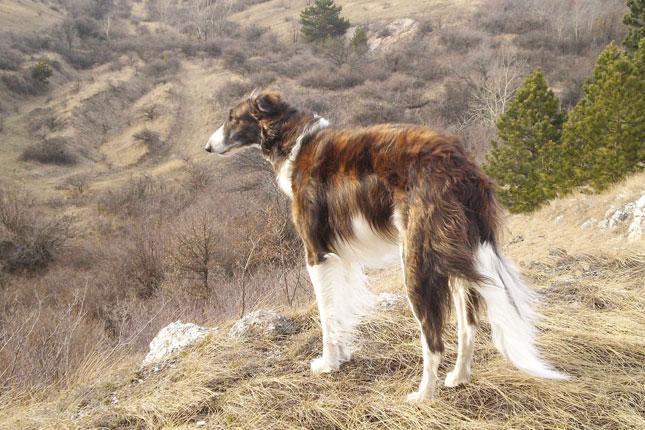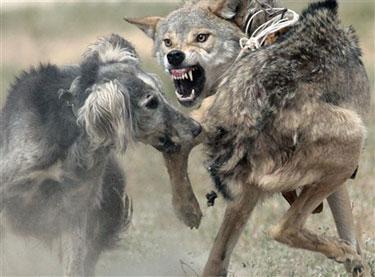The first image is the image on the left, the second image is the image on the right. Considering the images on both sides, is "An image shows exactly two pet hounds on grass." valid? Answer yes or no. No. The first image is the image on the left, the second image is the image on the right. Considering the images on both sides, is "One image shows a single dog standing in grass." valid? Answer yes or no. Yes. 